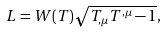<formula> <loc_0><loc_0><loc_500><loc_500>L = W ( T ) \sqrt { T _ { , \mu } T ^ { , \mu } - 1 } ,</formula> 